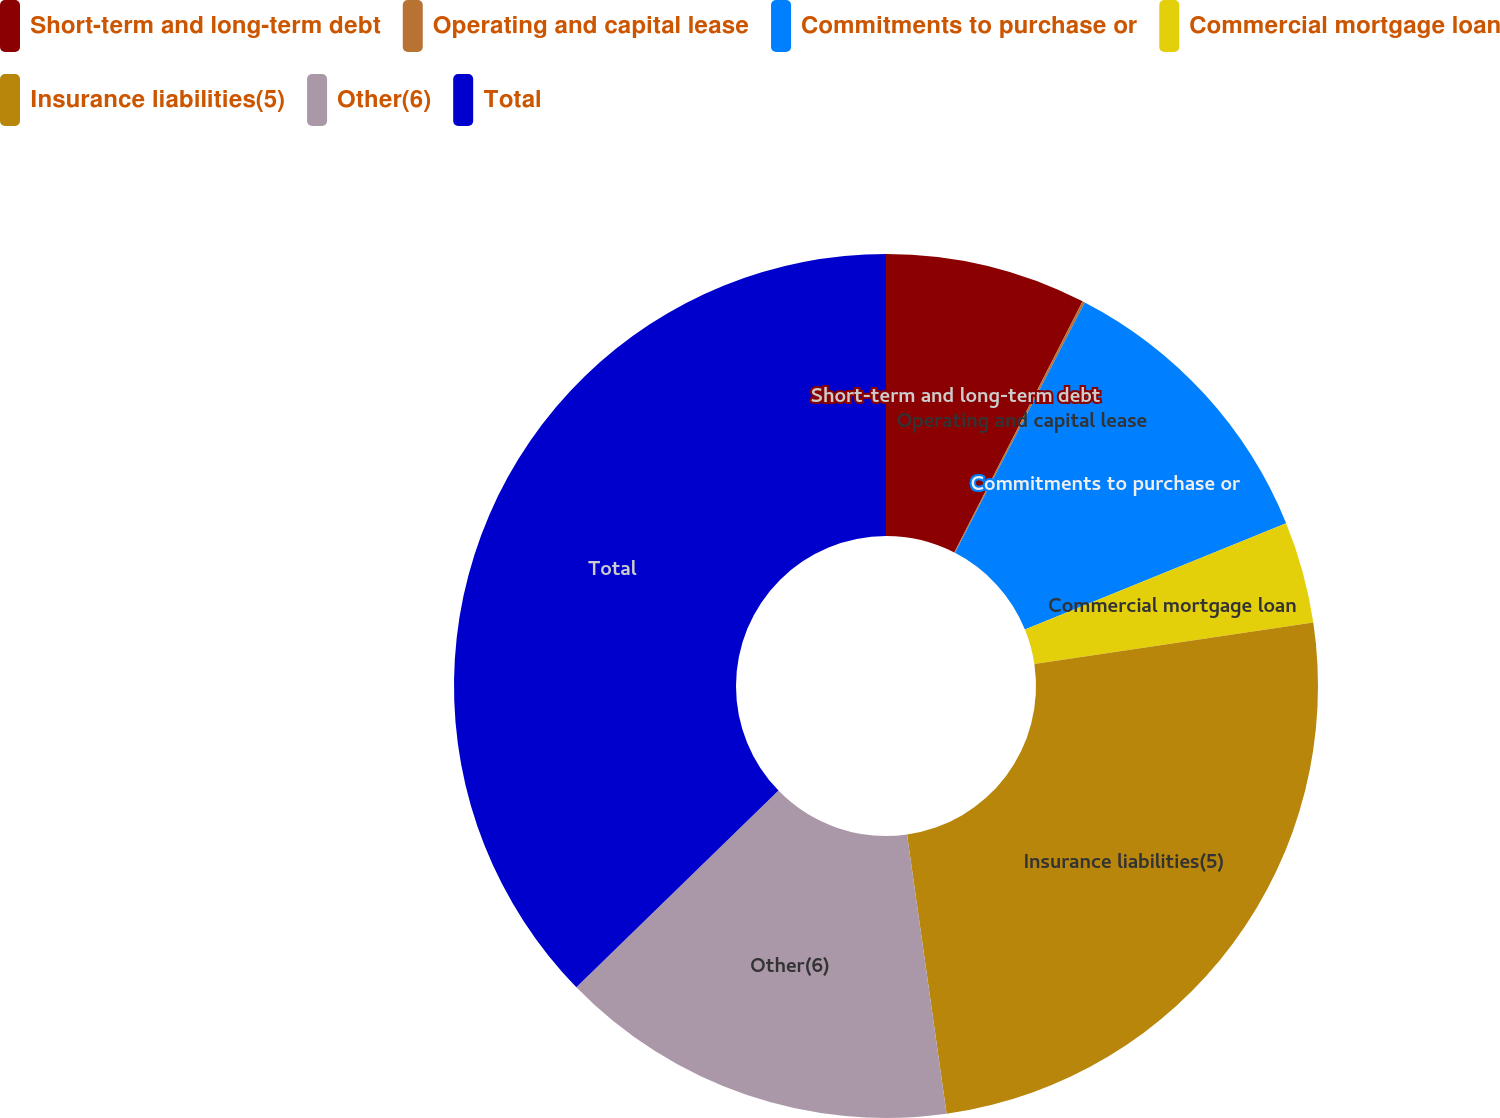Convert chart to OTSL. <chart><loc_0><loc_0><loc_500><loc_500><pie_chart><fcel>Short-term and long-term debt<fcel>Operating and capital lease<fcel>Commitments to purchase or<fcel>Commercial mortgage loan<fcel>Insurance liabilities(5)<fcel>Other(6)<fcel>Total<nl><fcel>7.52%<fcel>0.09%<fcel>11.24%<fcel>3.8%<fcel>25.11%<fcel>14.96%<fcel>37.28%<nl></chart> 